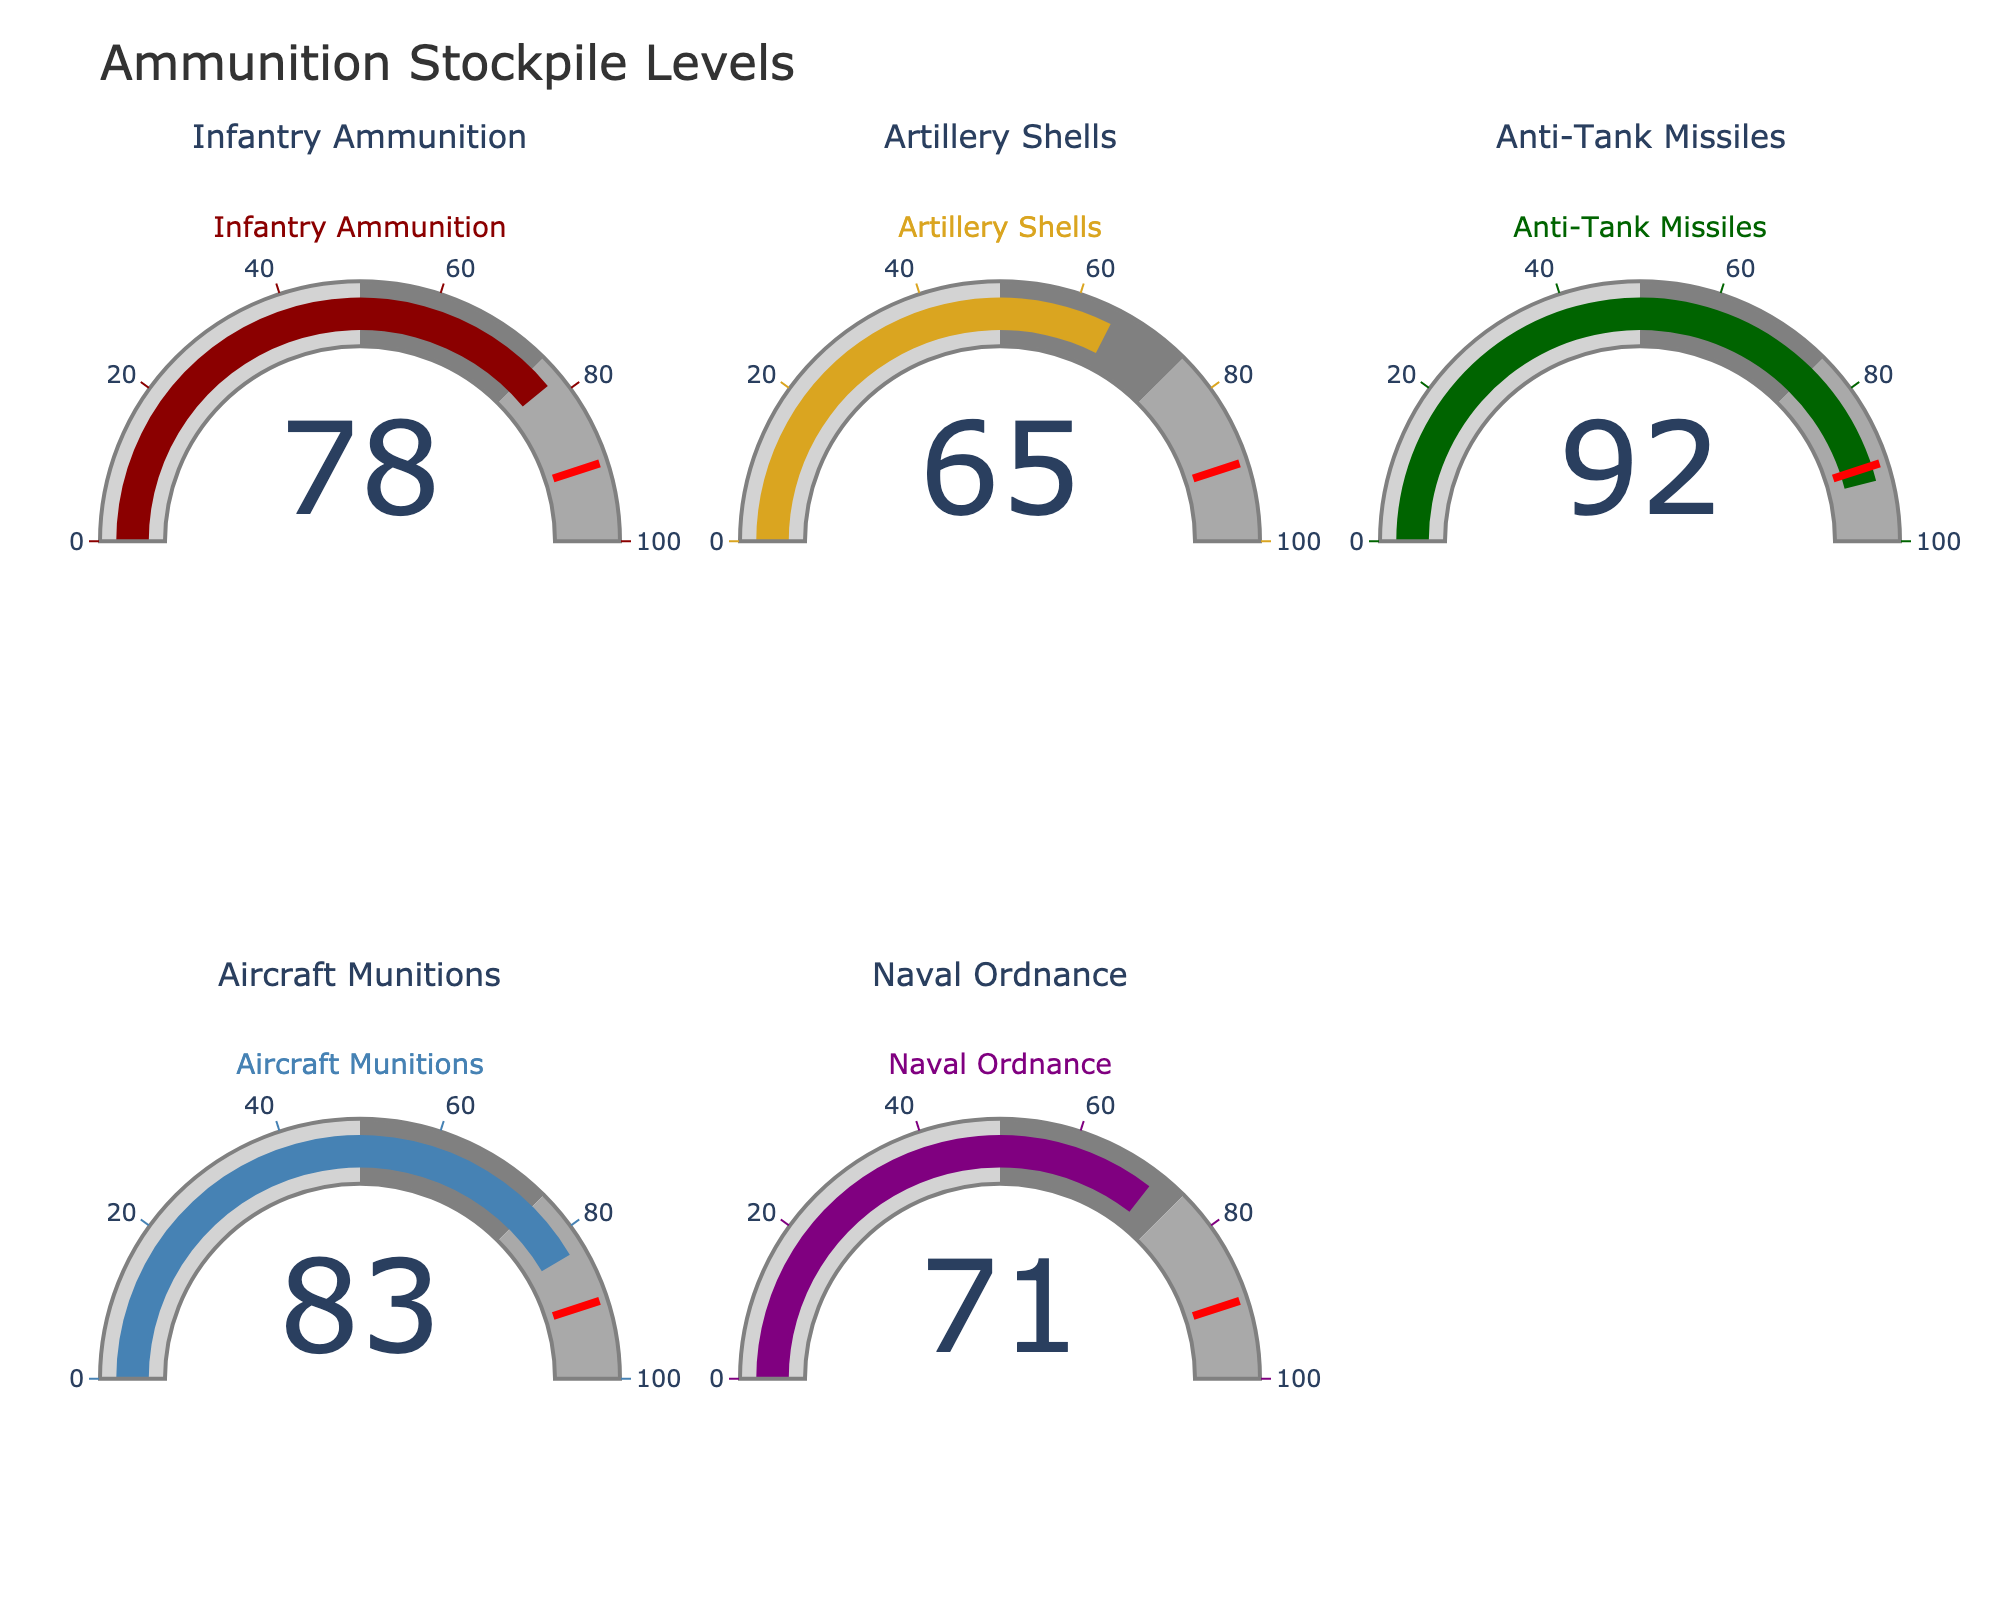What is the title of the figure? The title of the figure can be found at the top of the image. It states the main subject of the data being displayed.
Answer: Ammunition Stockpile Levels How many different types of ammunition are shown in the figure? Count the number of gauges shown in the figure, each representing a different type of ammunition.
Answer: Five Which type of ammunition has the highest stockpile level? Compare the values shown in each gauge. The highest value points to the type with the highest stockpile.
Answer: Anti-Tank Missiles Which ammunition type is closest to reaching the threshold value of 90%? Look at the value indicated in each gauge and compare them to the threshold line at 90%. Determine which value is closest but still below 90%.
Answer: Aircraft Munitions What is the combined percentage of Infantry Ammunition and Naval Ordnance? Add the percentages shown in the gauges for Infantry Ammunition and Naval Ordnance.
Answer: 149 How many types of ammunition have a stockpile level higher than 75%? Count how many gauges show values above 75%.
Answer: Three Are there any types of ammunition which stockpile level falls below 70%? If so, which ones? Check the values in each gauge and identify those below 70%.
Answer: Artillery Shells and Naval Ordnance Which type of ammunition has the lowest stockpile level? Look at the values in each gauge and find the lowest one.
Answer: Artillery Shells How does the stockpile level of Artillery Shells compare to Infantry Ammunition? Compare the percentage values of Artillery Shells and Infantry Ammunition to see which one is higher.
Answer: Artillery Shells have a lower percentage than Infantry Ammunition What is the percentage range that is represented by the darkest grey color in the gauge steps? Identify the color steps used in the gauge and their corresponding ranges. The darkest grey typically represents the highest range.
Answer: 75-100% 